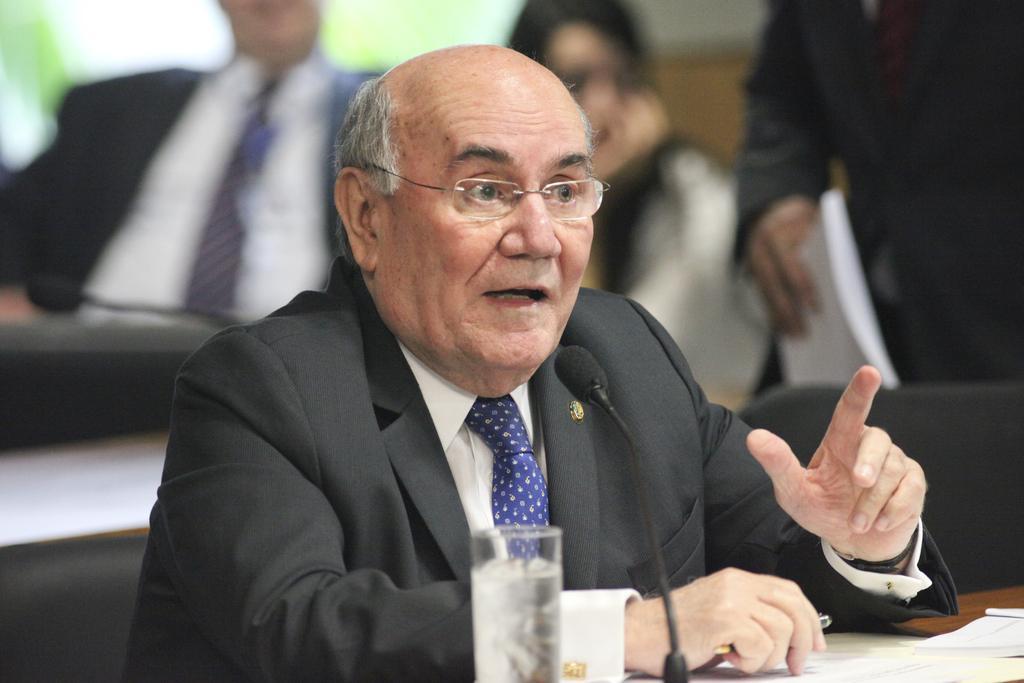Please provide a concise description of this image. In this image, I can see an old man sitting and talking. He wore a suit, shirt, tie and spectacles. This is the table with a mike, a glass of water and papers on it. In the background, I can see two people sitting and a person standing. I think this is an empty chair. 